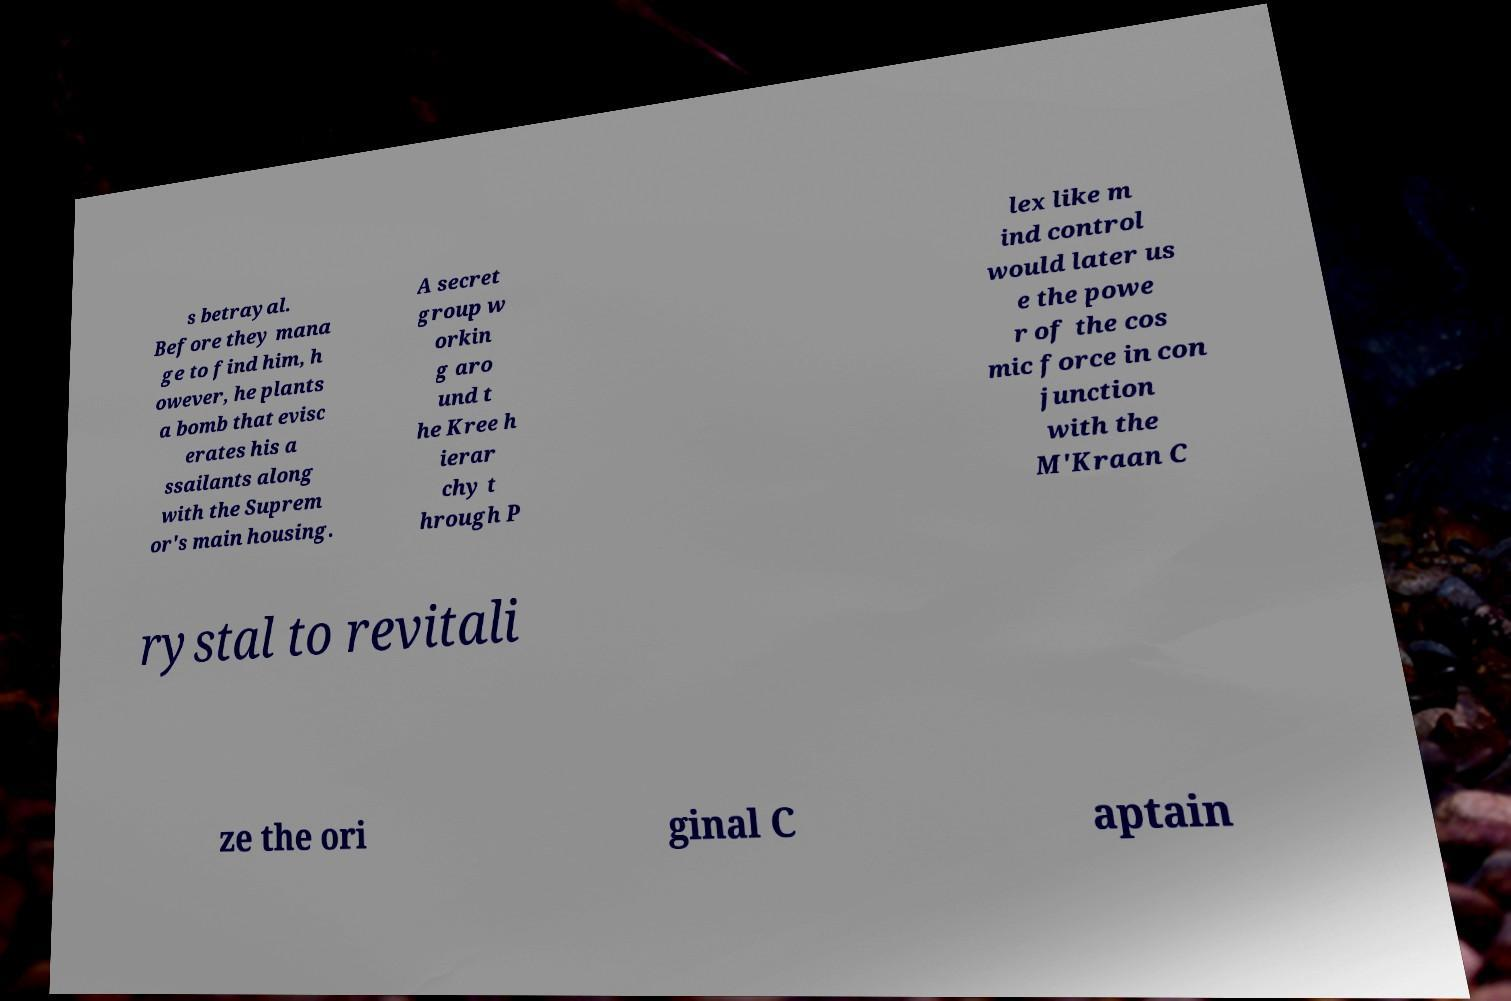There's text embedded in this image that I need extracted. Can you transcribe it verbatim? s betrayal. Before they mana ge to find him, h owever, he plants a bomb that evisc erates his a ssailants along with the Suprem or's main housing. A secret group w orkin g aro und t he Kree h ierar chy t hrough P lex like m ind control would later us e the powe r of the cos mic force in con junction with the M'Kraan C rystal to revitali ze the ori ginal C aptain 